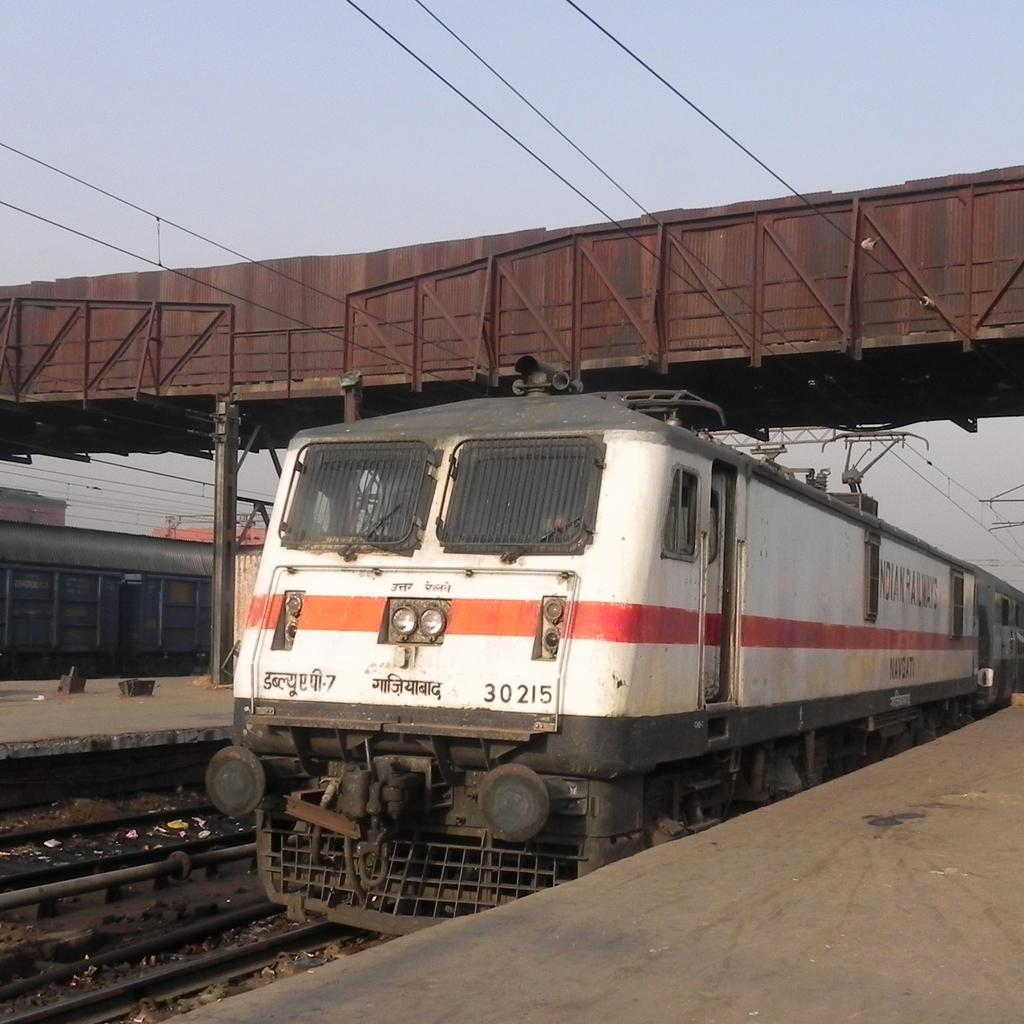Provide a one-sentence caption for the provided image. Train number 30215 is shown on the tracks. 